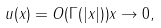Convert formula to latex. <formula><loc_0><loc_0><loc_500><loc_500>u ( x ) = O ( \Gamma ( | x | ) ) x \to 0 ,</formula> 